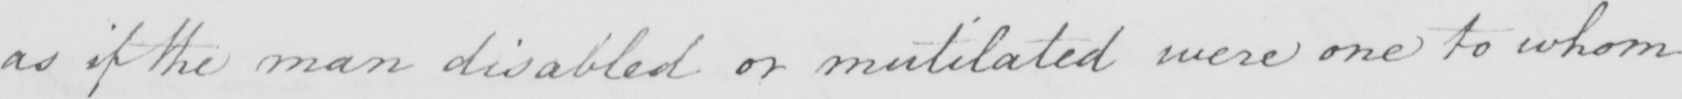Can you read and transcribe this handwriting? as if the man disabled or mutilated were one to whom 